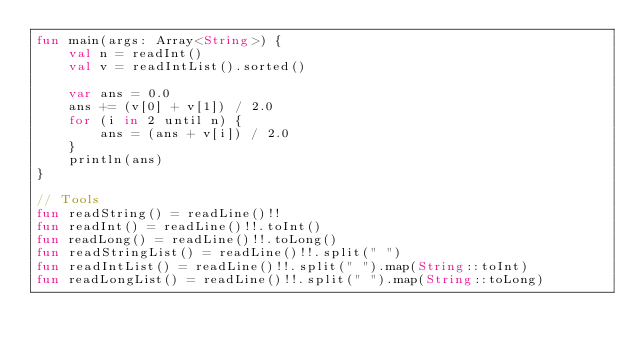<code> <loc_0><loc_0><loc_500><loc_500><_Kotlin_>fun main(args: Array<String>) {
    val n = readInt()
    val v = readIntList().sorted()

    var ans = 0.0
    ans += (v[0] + v[1]) / 2.0
    for (i in 2 until n) {
        ans = (ans + v[i]) / 2.0
    }
    println(ans)
}

// Tools
fun readString() = readLine()!!
fun readInt() = readLine()!!.toInt()
fun readLong() = readLine()!!.toLong()
fun readStringList() = readLine()!!.split(" ")
fun readIntList() = readLine()!!.split(" ").map(String::toInt)
fun readLongList() = readLine()!!.split(" ").map(String::toLong)</code> 